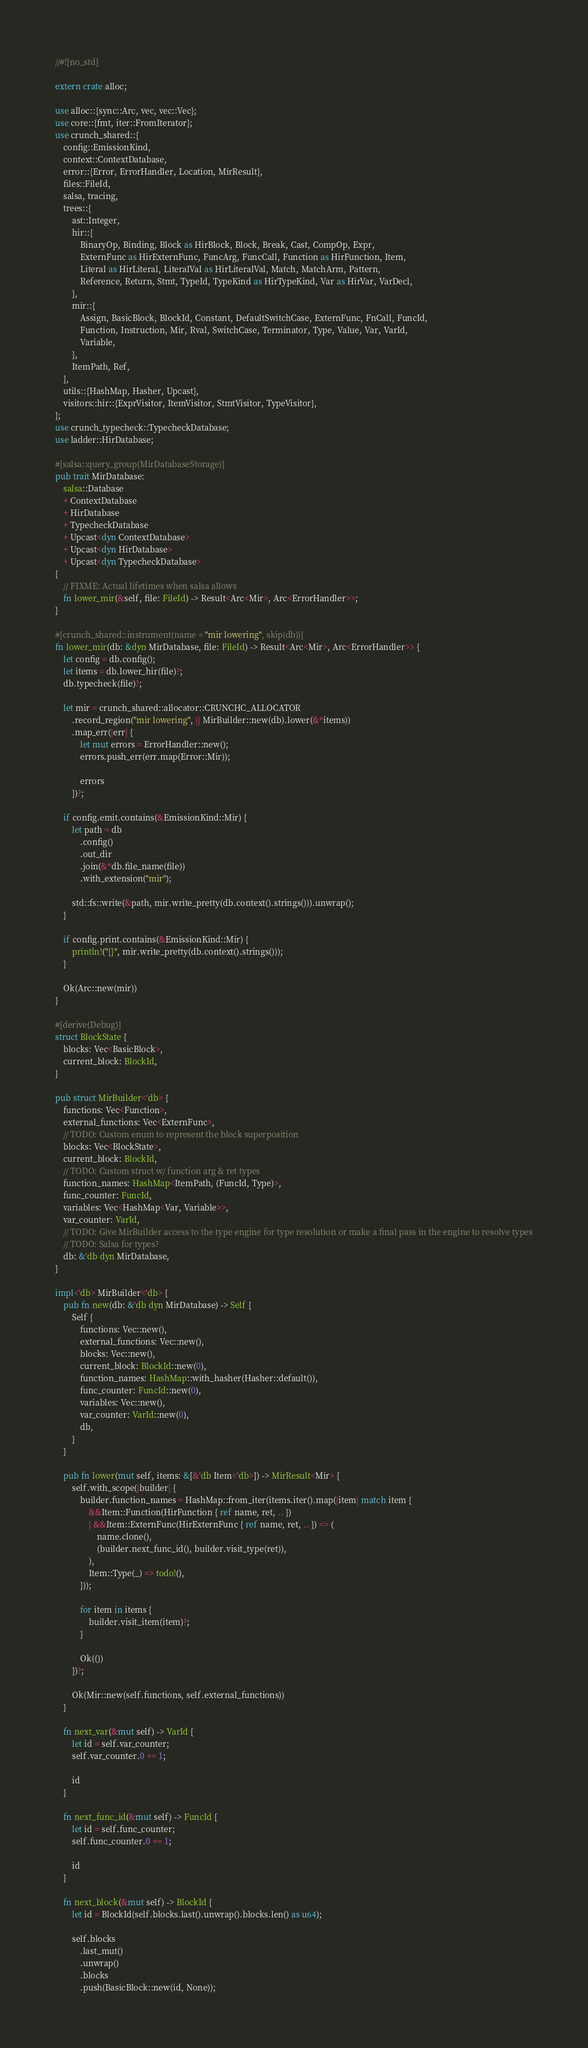<code> <loc_0><loc_0><loc_500><loc_500><_Rust_>//#![no_std]

extern crate alloc;

use alloc::{sync::Arc, vec, vec::Vec};
use core::{fmt, iter::FromIterator};
use crunch_shared::{
    config::EmissionKind,
    context::ContextDatabase,
    error::{Error, ErrorHandler, Location, MirResult},
    files::FileId,
    salsa, tracing,
    trees::{
        ast::Integer,
        hir::{
            BinaryOp, Binding, Block as HirBlock, Block, Break, Cast, CompOp, Expr,
            ExternFunc as HirExternFunc, FuncArg, FuncCall, Function as HirFunction, Item,
            Literal as HirLiteral, LiteralVal as HirLiteralVal, Match, MatchArm, Pattern,
            Reference, Return, Stmt, TypeId, TypeKind as HirTypeKind, Var as HirVar, VarDecl,
        },
        mir::{
            Assign, BasicBlock, BlockId, Constant, DefaultSwitchCase, ExternFunc, FnCall, FuncId,
            Function, Instruction, Mir, Rval, SwitchCase, Terminator, Type, Value, Var, VarId,
            Variable,
        },
        ItemPath, Ref,
    },
    utils::{HashMap, Hasher, Upcast},
    visitors::hir::{ExprVisitor, ItemVisitor, StmtVisitor, TypeVisitor},
};
use crunch_typecheck::TypecheckDatabase;
use ladder::HirDatabase;

#[salsa::query_group(MirDatabaseStorage)]
pub trait MirDatabase:
    salsa::Database
    + ContextDatabase
    + HirDatabase
    + TypecheckDatabase
    + Upcast<dyn ContextDatabase>
    + Upcast<dyn HirDatabase>
    + Upcast<dyn TypecheckDatabase>
{
    // FIXME: Actual lifetimes when salsa allows
    fn lower_mir(&self, file: FileId) -> Result<Arc<Mir>, Arc<ErrorHandler>>;
}

#[crunch_shared::instrument(name = "mir lowering", skip(db))]
fn lower_mir(db: &dyn MirDatabase, file: FileId) -> Result<Arc<Mir>, Arc<ErrorHandler>> {
    let config = db.config();
    let items = db.lower_hir(file)?;
    db.typecheck(file)?;

    let mir = crunch_shared::allocator::CRUNCHC_ALLOCATOR
        .record_region("mir lowering", || MirBuilder::new(db).lower(&*items))
        .map_err(|err| {
            let mut errors = ErrorHandler::new();
            errors.push_err(err.map(Error::Mir));

            errors
        })?;

    if config.emit.contains(&EmissionKind::Mir) {
        let path = db
            .config()
            .out_dir
            .join(&*db.file_name(file))
            .with_extension("mir");

        std::fs::write(&path, mir.write_pretty(db.context().strings())).unwrap();
    }

    if config.print.contains(&EmissionKind::Mir) {
        println!("{}", mir.write_pretty(db.context().strings()));
    }

    Ok(Arc::new(mir))
}

#[derive(Debug)]
struct BlockState {
    blocks: Vec<BasicBlock>,
    current_block: BlockId,
}

pub struct MirBuilder<'db> {
    functions: Vec<Function>,
    external_functions: Vec<ExternFunc>,
    // TODO: Custom enum to represent the block superposition
    blocks: Vec<BlockState>,
    current_block: BlockId,
    // TODO: Custom struct w/ function arg & ret types
    function_names: HashMap<ItemPath, (FuncId, Type)>,
    func_counter: FuncId,
    variables: Vec<HashMap<Var, Variable>>,
    var_counter: VarId,
    // TODO: Give MirBuilder access to the type engine for type resolution or make a final pass in the engine to resolve types
    // TODO: Salsa for types?
    db: &'db dyn MirDatabase,
}

impl<'db> MirBuilder<'db> {
    pub fn new(db: &'db dyn MirDatabase) -> Self {
        Self {
            functions: Vec::new(),
            external_functions: Vec::new(),
            blocks: Vec::new(),
            current_block: BlockId::new(0),
            function_names: HashMap::with_hasher(Hasher::default()),
            func_counter: FuncId::new(0),
            variables: Vec::new(),
            var_counter: VarId::new(0),
            db,
        }
    }

    pub fn lower(mut self, items: &[&'db Item<'db>]) -> MirResult<Mir> {
        self.with_scope(|builder| {
            builder.function_names = HashMap::from_iter(items.iter().map(|item| match item {
                &&Item::Function(HirFunction { ref name, ret, .. })
                | &&Item::ExternFunc(HirExternFunc { ref name, ret, .. }) => (
                    name.clone(),
                    (builder.next_func_id(), builder.visit_type(ret)),
                ),
                Item::Type(_) => todo!(),
            }));

            for item in items {
                builder.visit_item(item)?;
            }

            Ok(())
        })?;

        Ok(Mir::new(self.functions, self.external_functions))
    }

    fn next_var(&mut self) -> VarId {
        let id = self.var_counter;
        self.var_counter.0 += 1;

        id
    }

    fn next_func_id(&mut self) -> FuncId {
        let id = self.func_counter;
        self.func_counter.0 += 1;

        id
    }

    fn next_block(&mut self) -> BlockId {
        let id = BlockId(self.blocks.last().unwrap().blocks.len() as u64);

        self.blocks
            .last_mut()
            .unwrap()
            .blocks
            .push(BasicBlock::new(id, None));</code> 